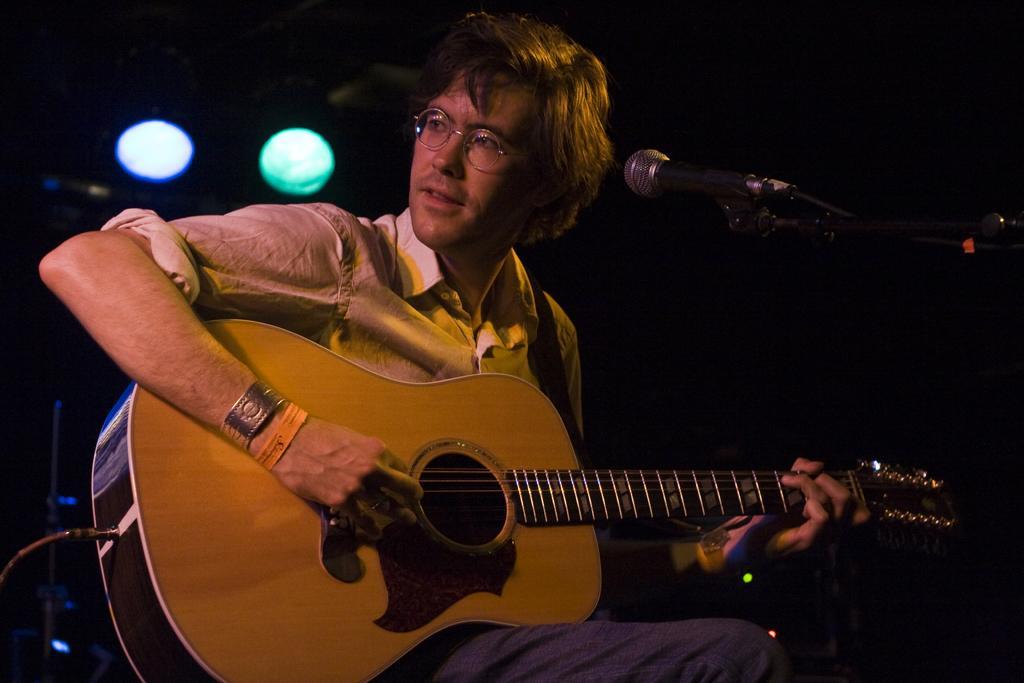How would you summarize this image in a sentence or two? In this image I can see a person wearing specs and a shirt. He is sitting in front of the mic and playing the guitar. In the background there is total black and I can see two lights. 